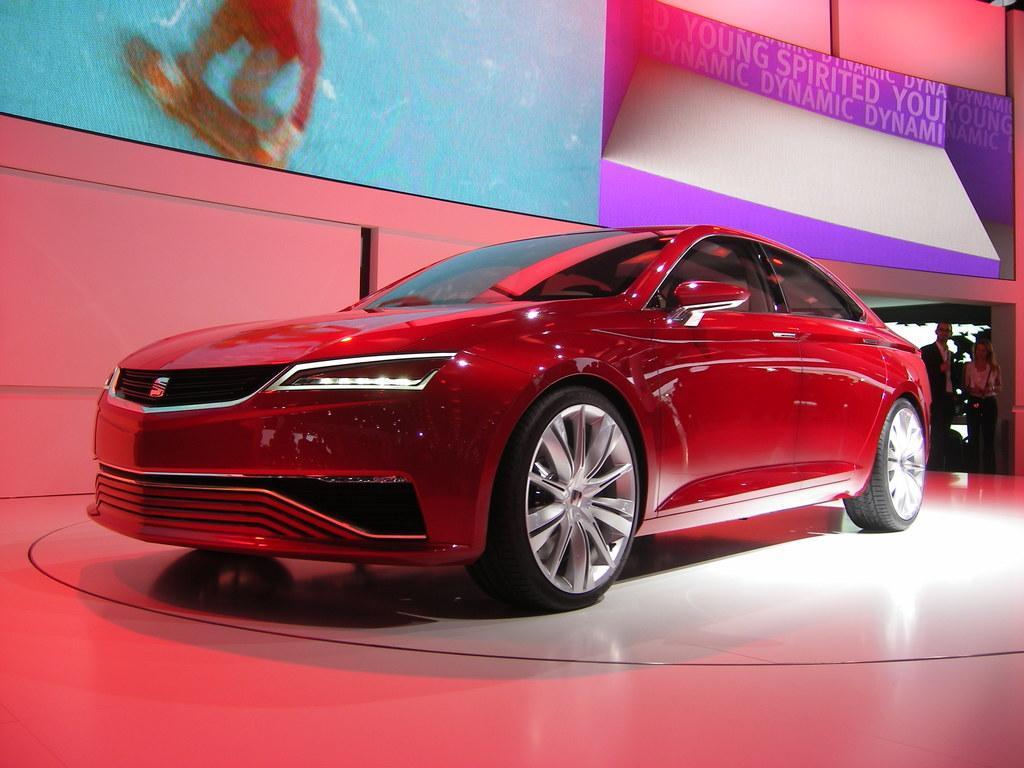In one or two sentences, can you explain what this image depicts? In this picture we can see a car on the floor and in the background we can see two people standing, wall, some objects. 